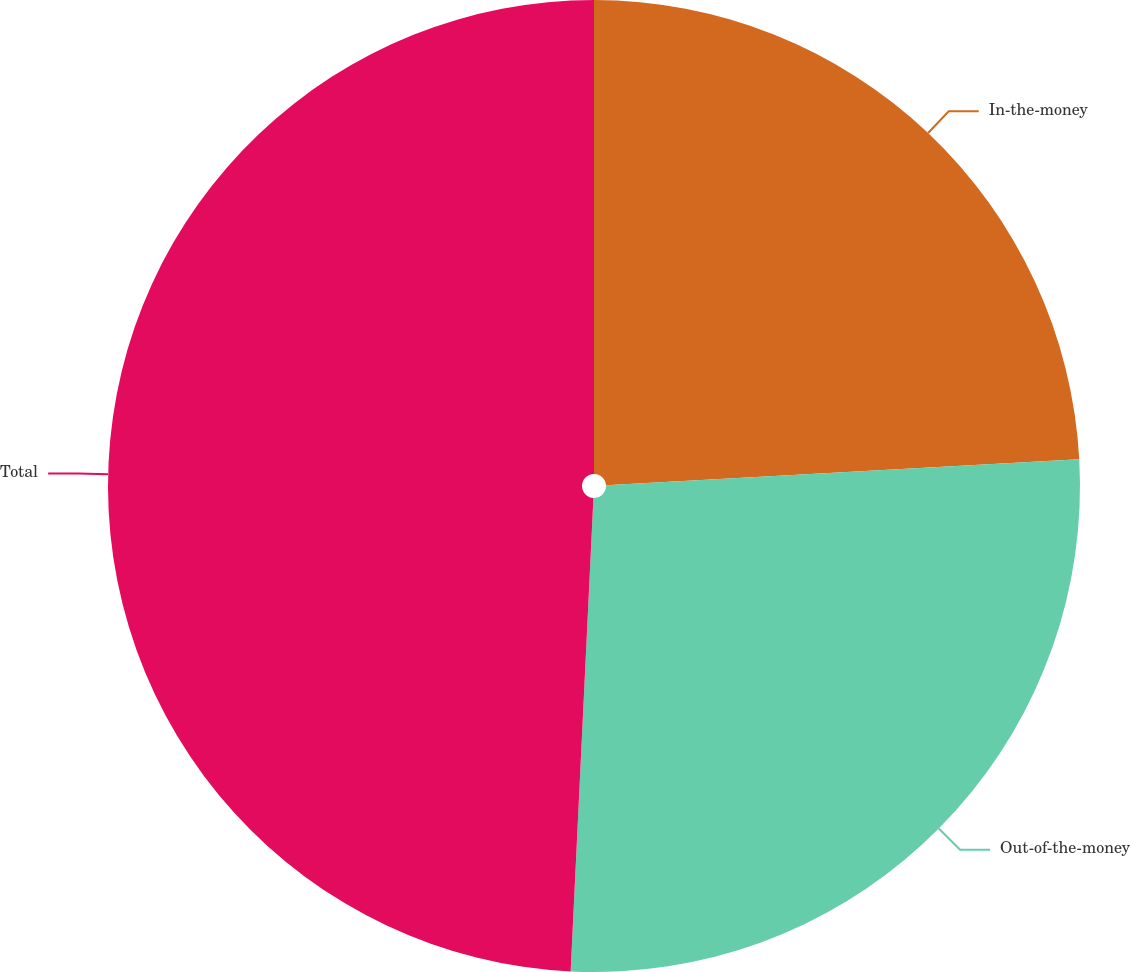<chart> <loc_0><loc_0><loc_500><loc_500><pie_chart><fcel>In-the-money<fcel>Out-of-the-money<fcel>Total<nl><fcel>24.13%<fcel>26.64%<fcel>49.24%<nl></chart> 